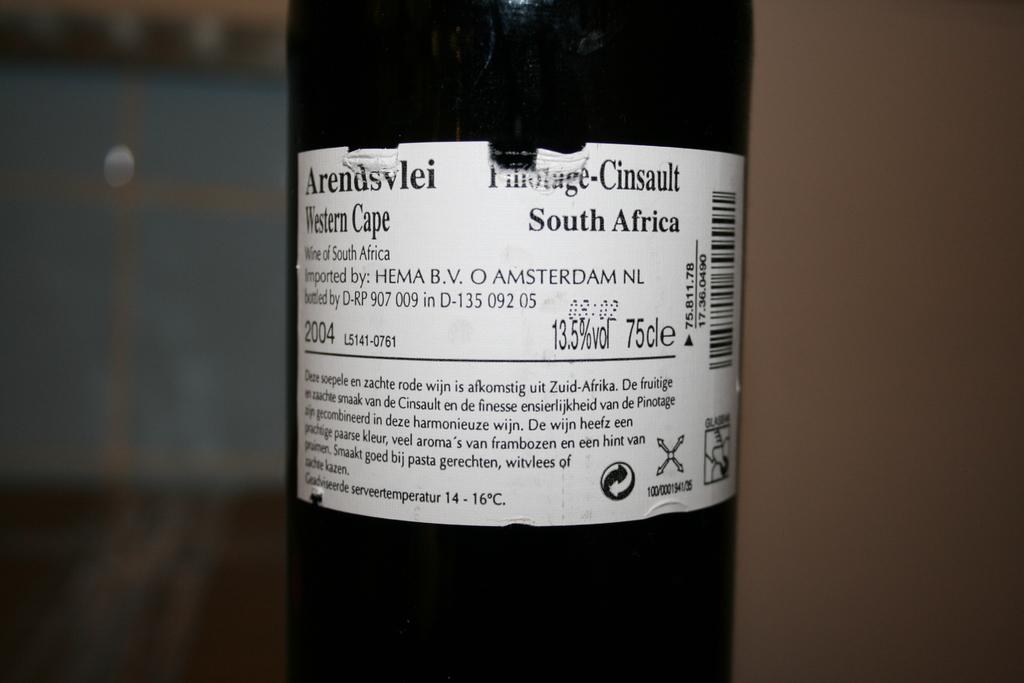<image>
Create a compact narrative representing the image presented. A bottle from South Africa says "Western Cape" on the label. 